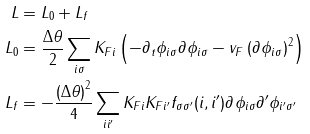<formula> <loc_0><loc_0><loc_500><loc_500>L & = L _ { 0 } + L _ { f } \\ L _ { 0 } & = \frac { \Delta \theta } { 2 } \sum _ { i \sigma } K _ { F i } \left ( - \partial _ { t } \phi _ { i \sigma } \partial _ { \| } \phi _ { i \sigma } - v _ { F } \left ( \partial _ { \| } \phi _ { i \sigma } \right ) ^ { 2 } \right ) \\ L _ { f } & = - \frac { \left ( \Delta \theta \right ) ^ { 2 } } { 4 } \sum _ { i i ^ { \prime } } K _ { F i } K _ { F i ^ { \prime } } f _ { \sigma \sigma ^ { \prime } } ( i , i ^ { \prime } ) \partial _ { \| } \phi _ { i \sigma } \partial ^ { \prime } _ { \| } \phi _ { i ^ { \prime } \sigma ^ { \prime } }</formula> 